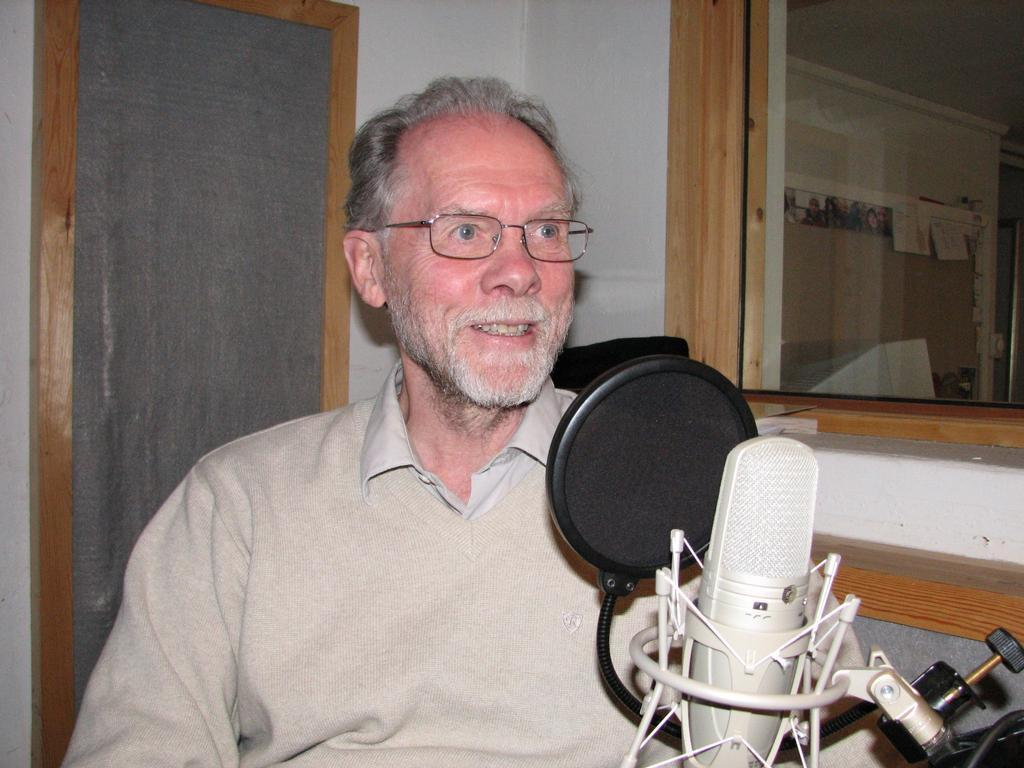What is the person in the image wearing? The person is wearing specs in the image. What is the position of the person in the image? The person is sitting in the image. What object is in front of the person? There is a mic in front of the person. What can be seen in the background of the image? There is a glass window and a wall in the background of the image. How many stars can be seen in the image? There are no stars visible in the image. What type of approval is the person seeking in the image? There is no indication in the image that the person is seeking any approval. 